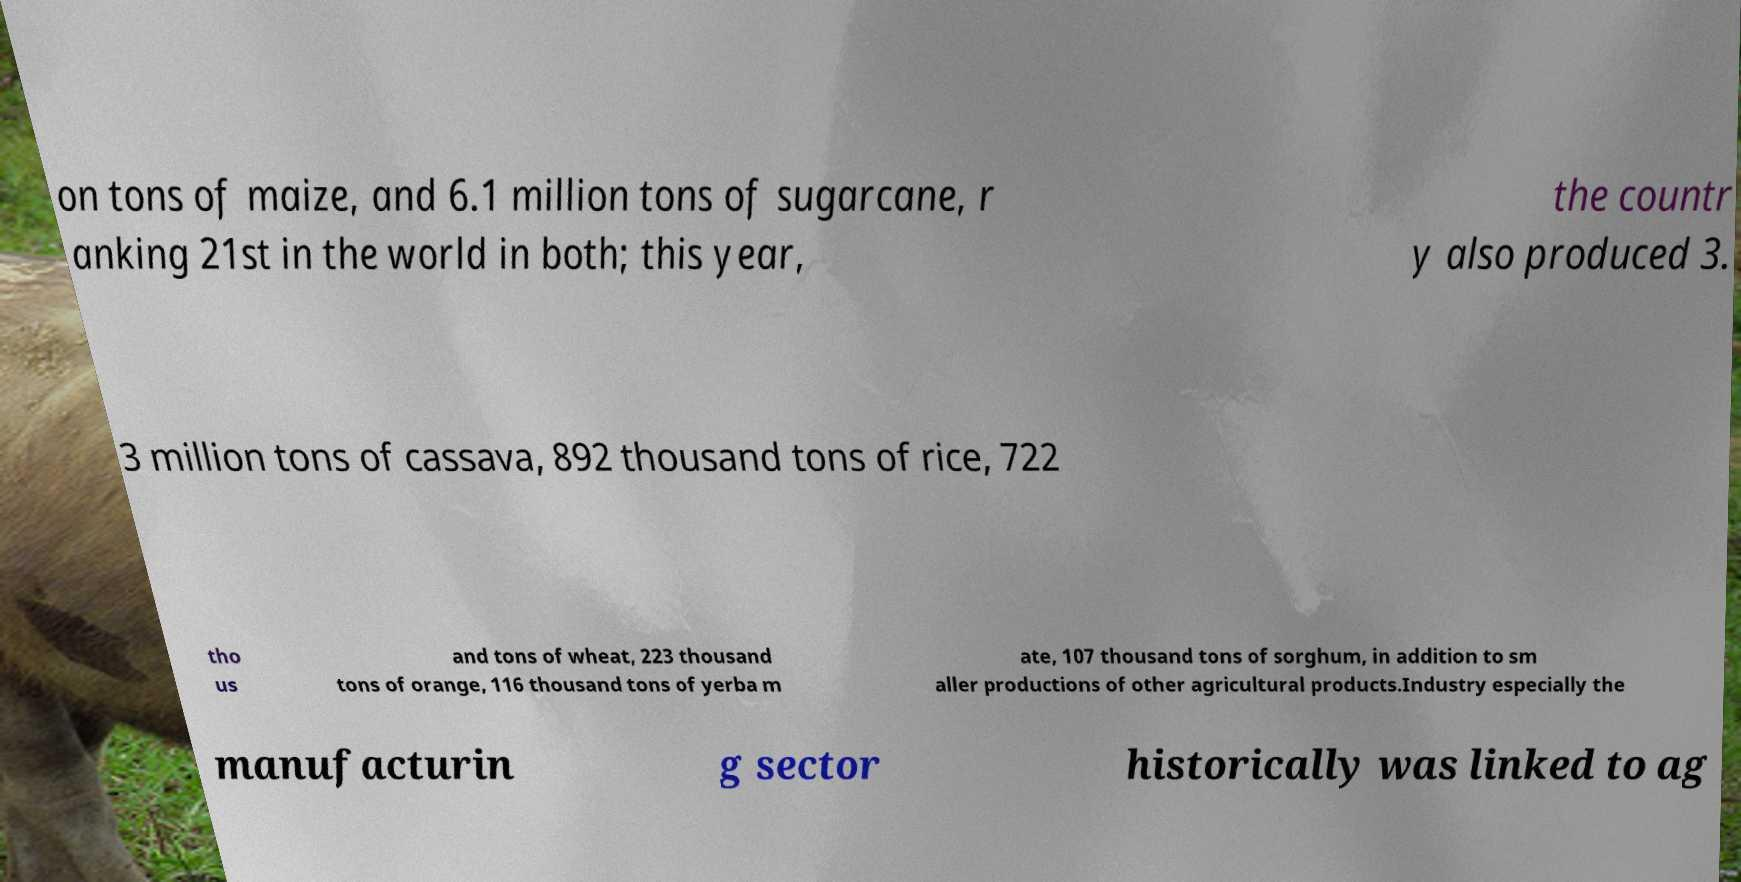For documentation purposes, I need the text within this image transcribed. Could you provide that? on tons of maize, and 6.1 million tons of sugarcane, r anking 21st in the world in both; this year, the countr y also produced 3. 3 million tons of cassava, 892 thousand tons of rice, 722 tho us and tons of wheat, 223 thousand tons of orange, 116 thousand tons of yerba m ate, 107 thousand tons of sorghum, in addition to sm aller productions of other agricultural products.Industry especially the manufacturin g sector historically was linked to ag 